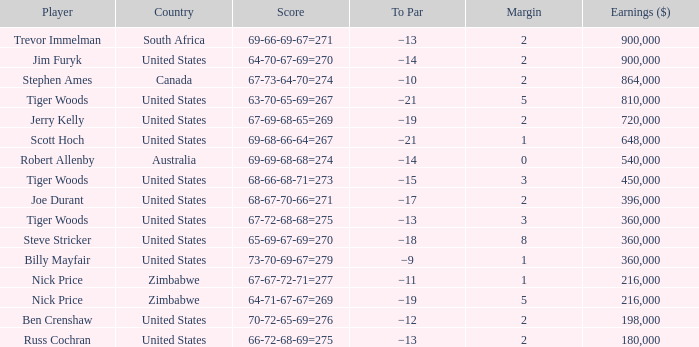Can you parse all the data within this table? {'header': ['Player', 'Country', 'Score', 'To Par', 'Margin', 'Earnings ($)'], 'rows': [['Trevor Immelman', 'South Africa', '69-66-69-67=271', '−13', '2', '900,000'], ['Jim Furyk', 'United States', '64-70-67-69=270', '−14', '2', '900,000'], ['Stephen Ames', 'Canada', '67-73-64-70=274', '−10', '2', '864,000'], ['Tiger Woods', 'United States', '63-70-65-69=267', '−21', '5', '810,000'], ['Jerry Kelly', 'United States', '67-69-68-65=269', '−19', '2', '720,000'], ['Scott Hoch', 'United States', '69-68-66-64=267', '−21', '1', '648,000'], ['Robert Allenby', 'Australia', '69-69-68-68=274', '−14', '0', '540,000'], ['Tiger Woods', 'United States', '68-66-68-71=273', '−15', '3', '450,000'], ['Joe Durant', 'United States', '68-67-70-66=271', '−17', '2', '396,000'], ['Tiger Woods', 'United States', '67-72-68-68=275', '−13', '3', '360,000'], ['Steve Stricker', 'United States', '65-69-67-69=270', '−18', '8', '360,000'], ['Billy Mayfair', 'United States', '73-70-69-67=279', '−9', '1', '360,000'], ['Nick Price', 'Zimbabwe', '67-67-72-71=277', '−11', '1', '216,000'], ['Nick Price', 'Zimbabwe', '64-71-67-67=269', '−19', '5', '216,000'], ['Ben Crenshaw', 'United States', '70-72-65-69=276', '−12', '2', '198,000'], ['Russ Cochran', 'United States', '66-72-68-69=275', '−13', '2', '180,000']]} How many years has a player comparable to joe durant accumulated, with earnings surpassing $396,000? 0.0. 